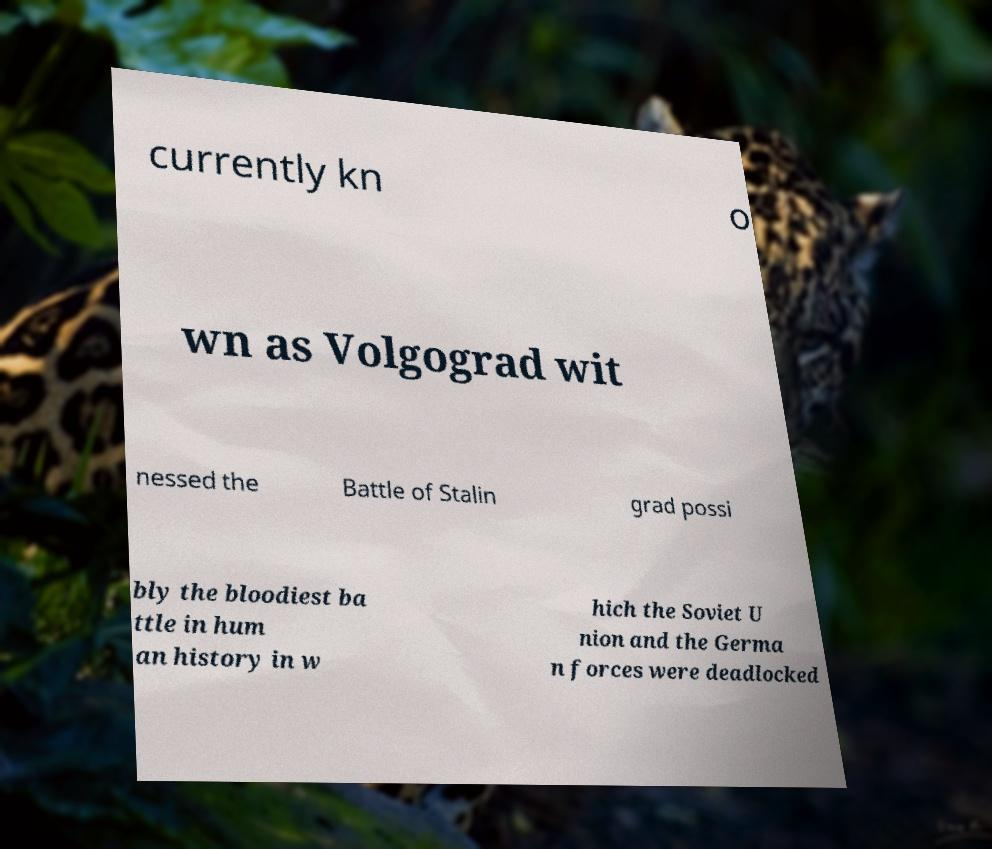There's text embedded in this image that I need extracted. Can you transcribe it verbatim? currently kn o wn as Volgograd wit nessed the Battle of Stalin grad possi bly the bloodiest ba ttle in hum an history in w hich the Soviet U nion and the Germa n forces were deadlocked 